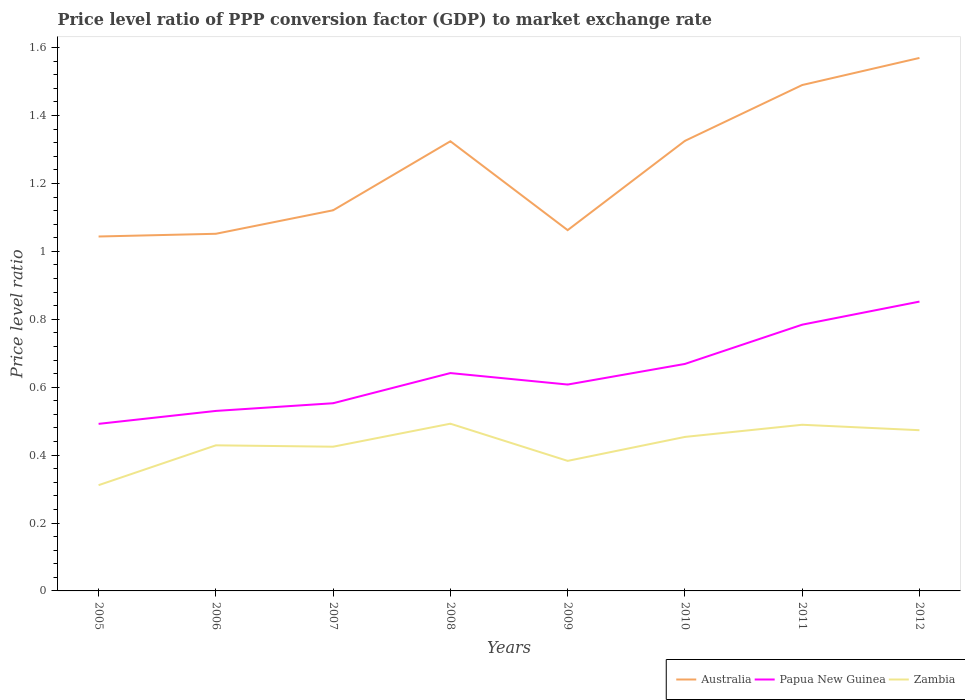Across all years, what is the maximum price level ratio in Zambia?
Offer a terse response. 0.31. What is the total price level ratio in Australia in the graph?
Offer a terse response. -0.27. What is the difference between the highest and the second highest price level ratio in Australia?
Offer a terse response. 0.53. What is the difference between the highest and the lowest price level ratio in Papua New Guinea?
Offer a terse response. 4. Is the price level ratio in Papua New Guinea strictly greater than the price level ratio in Australia over the years?
Provide a succinct answer. Yes. How many lines are there?
Make the answer very short. 3. How many years are there in the graph?
Provide a succinct answer. 8. Does the graph contain any zero values?
Your response must be concise. No. What is the title of the graph?
Your answer should be very brief. Price level ratio of PPP conversion factor (GDP) to market exchange rate. What is the label or title of the Y-axis?
Provide a succinct answer. Price level ratio. What is the Price level ratio of Australia in 2005?
Keep it short and to the point. 1.04. What is the Price level ratio of Papua New Guinea in 2005?
Ensure brevity in your answer.  0.49. What is the Price level ratio of Zambia in 2005?
Make the answer very short. 0.31. What is the Price level ratio of Australia in 2006?
Your answer should be compact. 1.05. What is the Price level ratio in Papua New Guinea in 2006?
Your answer should be compact. 0.53. What is the Price level ratio in Zambia in 2006?
Provide a succinct answer. 0.43. What is the Price level ratio of Australia in 2007?
Provide a short and direct response. 1.12. What is the Price level ratio in Papua New Guinea in 2007?
Keep it short and to the point. 0.55. What is the Price level ratio of Zambia in 2007?
Ensure brevity in your answer.  0.42. What is the Price level ratio in Australia in 2008?
Keep it short and to the point. 1.32. What is the Price level ratio of Papua New Guinea in 2008?
Give a very brief answer. 0.64. What is the Price level ratio in Zambia in 2008?
Your answer should be very brief. 0.49. What is the Price level ratio of Australia in 2009?
Your answer should be compact. 1.06. What is the Price level ratio in Papua New Guinea in 2009?
Your answer should be very brief. 0.61. What is the Price level ratio of Zambia in 2009?
Your response must be concise. 0.38. What is the Price level ratio of Australia in 2010?
Offer a very short reply. 1.33. What is the Price level ratio of Papua New Guinea in 2010?
Ensure brevity in your answer.  0.67. What is the Price level ratio in Zambia in 2010?
Keep it short and to the point. 0.45. What is the Price level ratio of Australia in 2011?
Provide a succinct answer. 1.49. What is the Price level ratio in Papua New Guinea in 2011?
Provide a short and direct response. 0.78. What is the Price level ratio in Zambia in 2011?
Make the answer very short. 0.49. What is the Price level ratio in Australia in 2012?
Provide a succinct answer. 1.57. What is the Price level ratio in Papua New Guinea in 2012?
Your answer should be very brief. 0.85. What is the Price level ratio of Zambia in 2012?
Your answer should be very brief. 0.47. Across all years, what is the maximum Price level ratio in Australia?
Ensure brevity in your answer.  1.57. Across all years, what is the maximum Price level ratio in Papua New Guinea?
Keep it short and to the point. 0.85. Across all years, what is the maximum Price level ratio in Zambia?
Keep it short and to the point. 0.49. Across all years, what is the minimum Price level ratio in Australia?
Your answer should be compact. 1.04. Across all years, what is the minimum Price level ratio of Papua New Guinea?
Provide a short and direct response. 0.49. Across all years, what is the minimum Price level ratio in Zambia?
Give a very brief answer. 0.31. What is the total Price level ratio in Australia in the graph?
Give a very brief answer. 9.99. What is the total Price level ratio in Papua New Guinea in the graph?
Offer a terse response. 5.13. What is the total Price level ratio of Zambia in the graph?
Provide a succinct answer. 3.46. What is the difference between the Price level ratio of Australia in 2005 and that in 2006?
Ensure brevity in your answer.  -0.01. What is the difference between the Price level ratio of Papua New Guinea in 2005 and that in 2006?
Make the answer very short. -0.04. What is the difference between the Price level ratio of Zambia in 2005 and that in 2006?
Provide a short and direct response. -0.12. What is the difference between the Price level ratio in Australia in 2005 and that in 2007?
Give a very brief answer. -0.08. What is the difference between the Price level ratio in Papua New Guinea in 2005 and that in 2007?
Keep it short and to the point. -0.06. What is the difference between the Price level ratio of Zambia in 2005 and that in 2007?
Your answer should be compact. -0.11. What is the difference between the Price level ratio in Australia in 2005 and that in 2008?
Offer a very short reply. -0.28. What is the difference between the Price level ratio in Papua New Guinea in 2005 and that in 2008?
Provide a short and direct response. -0.15. What is the difference between the Price level ratio of Zambia in 2005 and that in 2008?
Keep it short and to the point. -0.18. What is the difference between the Price level ratio of Australia in 2005 and that in 2009?
Give a very brief answer. -0.02. What is the difference between the Price level ratio of Papua New Guinea in 2005 and that in 2009?
Ensure brevity in your answer.  -0.12. What is the difference between the Price level ratio of Zambia in 2005 and that in 2009?
Offer a terse response. -0.07. What is the difference between the Price level ratio in Australia in 2005 and that in 2010?
Your answer should be compact. -0.28. What is the difference between the Price level ratio in Papua New Guinea in 2005 and that in 2010?
Provide a succinct answer. -0.18. What is the difference between the Price level ratio in Zambia in 2005 and that in 2010?
Provide a short and direct response. -0.14. What is the difference between the Price level ratio in Australia in 2005 and that in 2011?
Provide a short and direct response. -0.45. What is the difference between the Price level ratio of Papua New Guinea in 2005 and that in 2011?
Make the answer very short. -0.29. What is the difference between the Price level ratio of Zambia in 2005 and that in 2011?
Keep it short and to the point. -0.18. What is the difference between the Price level ratio in Australia in 2005 and that in 2012?
Provide a succinct answer. -0.53. What is the difference between the Price level ratio in Papua New Guinea in 2005 and that in 2012?
Give a very brief answer. -0.36. What is the difference between the Price level ratio in Zambia in 2005 and that in 2012?
Your answer should be compact. -0.16. What is the difference between the Price level ratio in Australia in 2006 and that in 2007?
Keep it short and to the point. -0.07. What is the difference between the Price level ratio in Papua New Guinea in 2006 and that in 2007?
Your answer should be compact. -0.02. What is the difference between the Price level ratio of Zambia in 2006 and that in 2007?
Make the answer very short. 0. What is the difference between the Price level ratio of Australia in 2006 and that in 2008?
Make the answer very short. -0.27. What is the difference between the Price level ratio of Papua New Guinea in 2006 and that in 2008?
Your response must be concise. -0.11. What is the difference between the Price level ratio of Zambia in 2006 and that in 2008?
Make the answer very short. -0.06. What is the difference between the Price level ratio in Australia in 2006 and that in 2009?
Offer a terse response. -0.01. What is the difference between the Price level ratio in Papua New Guinea in 2006 and that in 2009?
Your answer should be very brief. -0.08. What is the difference between the Price level ratio in Zambia in 2006 and that in 2009?
Give a very brief answer. 0.05. What is the difference between the Price level ratio in Australia in 2006 and that in 2010?
Offer a terse response. -0.27. What is the difference between the Price level ratio of Papua New Guinea in 2006 and that in 2010?
Your answer should be very brief. -0.14. What is the difference between the Price level ratio of Zambia in 2006 and that in 2010?
Ensure brevity in your answer.  -0.02. What is the difference between the Price level ratio in Australia in 2006 and that in 2011?
Your answer should be compact. -0.44. What is the difference between the Price level ratio in Papua New Guinea in 2006 and that in 2011?
Your answer should be compact. -0.25. What is the difference between the Price level ratio in Zambia in 2006 and that in 2011?
Your answer should be compact. -0.06. What is the difference between the Price level ratio of Australia in 2006 and that in 2012?
Your response must be concise. -0.52. What is the difference between the Price level ratio in Papua New Guinea in 2006 and that in 2012?
Offer a very short reply. -0.32. What is the difference between the Price level ratio of Zambia in 2006 and that in 2012?
Give a very brief answer. -0.04. What is the difference between the Price level ratio of Australia in 2007 and that in 2008?
Provide a short and direct response. -0.2. What is the difference between the Price level ratio in Papua New Guinea in 2007 and that in 2008?
Give a very brief answer. -0.09. What is the difference between the Price level ratio of Zambia in 2007 and that in 2008?
Offer a terse response. -0.07. What is the difference between the Price level ratio in Australia in 2007 and that in 2009?
Offer a very short reply. 0.06. What is the difference between the Price level ratio in Papua New Guinea in 2007 and that in 2009?
Offer a terse response. -0.06. What is the difference between the Price level ratio in Zambia in 2007 and that in 2009?
Keep it short and to the point. 0.04. What is the difference between the Price level ratio in Australia in 2007 and that in 2010?
Ensure brevity in your answer.  -0.2. What is the difference between the Price level ratio of Papua New Guinea in 2007 and that in 2010?
Give a very brief answer. -0.12. What is the difference between the Price level ratio in Zambia in 2007 and that in 2010?
Provide a short and direct response. -0.03. What is the difference between the Price level ratio of Australia in 2007 and that in 2011?
Provide a succinct answer. -0.37. What is the difference between the Price level ratio in Papua New Guinea in 2007 and that in 2011?
Your response must be concise. -0.23. What is the difference between the Price level ratio of Zambia in 2007 and that in 2011?
Offer a very short reply. -0.06. What is the difference between the Price level ratio in Australia in 2007 and that in 2012?
Provide a short and direct response. -0.45. What is the difference between the Price level ratio of Papua New Guinea in 2007 and that in 2012?
Ensure brevity in your answer.  -0.3. What is the difference between the Price level ratio of Zambia in 2007 and that in 2012?
Your response must be concise. -0.05. What is the difference between the Price level ratio of Australia in 2008 and that in 2009?
Make the answer very short. 0.26. What is the difference between the Price level ratio in Papua New Guinea in 2008 and that in 2009?
Offer a very short reply. 0.03. What is the difference between the Price level ratio in Zambia in 2008 and that in 2009?
Offer a very short reply. 0.11. What is the difference between the Price level ratio in Australia in 2008 and that in 2010?
Provide a short and direct response. -0. What is the difference between the Price level ratio in Papua New Guinea in 2008 and that in 2010?
Provide a short and direct response. -0.03. What is the difference between the Price level ratio of Zambia in 2008 and that in 2010?
Ensure brevity in your answer.  0.04. What is the difference between the Price level ratio in Australia in 2008 and that in 2011?
Provide a short and direct response. -0.17. What is the difference between the Price level ratio of Papua New Guinea in 2008 and that in 2011?
Give a very brief answer. -0.14. What is the difference between the Price level ratio of Zambia in 2008 and that in 2011?
Your answer should be very brief. 0. What is the difference between the Price level ratio in Australia in 2008 and that in 2012?
Your response must be concise. -0.25. What is the difference between the Price level ratio in Papua New Guinea in 2008 and that in 2012?
Provide a short and direct response. -0.21. What is the difference between the Price level ratio in Zambia in 2008 and that in 2012?
Provide a short and direct response. 0.02. What is the difference between the Price level ratio in Australia in 2009 and that in 2010?
Provide a short and direct response. -0.26. What is the difference between the Price level ratio of Papua New Guinea in 2009 and that in 2010?
Your answer should be compact. -0.06. What is the difference between the Price level ratio of Zambia in 2009 and that in 2010?
Your answer should be compact. -0.07. What is the difference between the Price level ratio of Australia in 2009 and that in 2011?
Provide a short and direct response. -0.43. What is the difference between the Price level ratio of Papua New Guinea in 2009 and that in 2011?
Make the answer very short. -0.18. What is the difference between the Price level ratio of Zambia in 2009 and that in 2011?
Ensure brevity in your answer.  -0.11. What is the difference between the Price level ratio of Australia in 2009 and that in 2012?
Make the answer very short. -0.51. What is the difference between the Price level ratio of Papua New Guinea in 2009 and that in 2012?
Give a very brief answer. -0.24. What is the difference between the Price level ratio in Zambia in 2009 and that in 2012?
Offer a terse response. -0.09. What is the difference between the Price level ratio in Australia in 2010 and that in 2011?
Your answer should be very brief. -0.16. What is the difference between the Price level ratio of Papua New Guinea in 2010 and that in 2011?
Your answer should be compact. -0.12. What is the difference between the Price level ratio in Zambia in 2010 and that in 2011?
Provide a succinct answer. -0.04. What is the difference between the Price level ratio in Australia in 2010 and that in 2012?
Make the answer very short. -0.24. What is the difference between the Price level ratio of Papua New Guinea in 2010 and that in 2012?
Offer a very short reply. -0.18. What is the difference between the Price level ratio in Zambia in 2010 and that in 2012?
Keep it short and to the point. -0.02. What is the difference between the Price level ratio of Australia in 2011 and that in 2012?
Your answer should be very brief. -0.08. What is the difference between the Price level ratio of Papua New Guinea in 2011 and that in 2012?
Give a very brief answer. -0.07. What is the difference between the Price level ratio of Zambia in 2011 and that in 2012?
Provide a succinct answer. 0.02. What is the difference between the Price level ratio in Australia in 2005 and the Price level ratio in Papua New Guinea in 2006?
Provide a succinct answer. 0.51. What is the difference between the Price level ratio in Australia in 2005 and the Price level ratio in Zambia in 2006?
Your answer should be very brief. 0.61. What is the difference between the Price level ratio in Papua New Guinea in 2005 and the Price level ratio in Zambia in 2006?
Your answer should be compact. 0.06. What is the difference between the Price level ratio of Australia in 2005 and the Price level ratio of Papua New Guinea in 2007?
Give a very brief answer. 0.49. What is the difference between the Price level ratio in Australia in 2005 and the Price level ratio in Zambia in 2007?
Keep it short and to the point. 0.62. What is the difference between the Price level ratio in Papua New Guinea in 2005 and the Price level ratio in Zambia in 2007?
Offer a very short reply. 0.07. What is the difference between the Price level ratio of Australia in 2005 and the Price level ratio of Papua New Guinea in 2008?
Provide a short and direct response. 0.4. What is the difference between the Price level ratio in Australia in 2005 and the Price level ratio in Zambia in 2008?
Ensure brevity in your answer.  0.55. What is the difference between the Price level ratio in Papua New Guinea in 2005 and the Price level ratio in Zambia in 2008?
Give a very brief answer. -0. What is the difference between the Price level ratio in Australia in 2005 and the Price level ratio in Papua New Guinea in 2009?
Provide a succinct answer. 0.44. What is the difference between the Price level ratio of Australia in 2005 and the Price level ratio of Zambia in 2009?
Give a very brief answer. 0.66. What is the difference between the Price level ratio of Papua New Guinea in 2005 and the Price level ratio of Zambia in 2009?
Give a very brief answer. 0.11. What is the difference between the Price level ratio of Australia in 2005 and the Price level ratio of Papua New Guinea in 2010?
Your answer should be compact. 0.38. What is the difference between the Price level ratio of Australia in 2005 and the Price level ratio of Zambia in 2010?
Provide a short and direct response. 0.59. What is the difference between the Price level ratio in Papua New Guinea in 2005 and the Price level ratio in Zambia in 2010?
Your response must be concise. 0.04. What is the difference between the Price level ratio of Australia in 2005 and the Price level ratio of Papua New Guinea in 2011?
Your response must be concise. 0.26. What is the difference between the Price level ratio of Australia in 2005 and the Price level ratio of Zambia in 2011?
Offer a terse response. 0.55. What is the difference between the Price level ratio of Papua New Guinea in 2005 and the Price level ratio of Zambia in 2011?
Ensure brevity in your answer.  0. What is the difference between the Price level ratio of Australia in 2005 and the Price level ratio of Papua New Guinea in 2012?
Ensure brevity in your answer.  0.19. What is the difference between the Price level ratio of Australia in 2005 and the Price level ratio of Zambia in 2012?
Keep it short and to the point. 0.57. What is the difference between the Price level ratio in Papua New Guinea in 2005 and the Price level ratio in Zambia in 2012?
Give a very brief answer. 0.02. What is the difference between the Price level ratio in Australia in 2006 and the Price level ratio in Papua New Guinea in 2007?
Give a very brief answer. 0.5. What is the difference between the Price level ratio of Australia in 2006 and the Price level ratio of Zambia in 2007?
Offer a very short reply. 0.63. What is the difference between the Price level ratio in Papua New Guinea in 2006 and the Price level ratio in Zambia in 2007?
Keep it short and to the point. 0.11. What is the difference between the Price level ratio in Australia in 2006 and the Price level ratio in Papua New Guinea in 2008?
Offer a very short reply. 0.41. What is the difference between the Price level ratio in Australia in 2006 and the Price level ratio in Zambia in 2008?
Offer a terse response. 0.56. What is the difference between the Price level ratio in Papua New Guinea in 2006 and the Price level ratio in Zambia in 2008?
Your answer should be very brief. 0.04. What is the difference between the Price level ratio in Australia in 2006 and the Price level ratio in Papua New Guinea in 2009?
Provide a succinct answer. 0.44. What is the difference between the Price level ratio of Australia in 2006 and the Price level ratio of Zambia in 2009?
Your answer should be very brief. 0.67. What is the difference between the Price level ratio in Papua New Guinea in 2006 and the Price level ratio in Zambia in 2009?
Ensure brevity in your answer.  0.15. What is the difference between the Price level ratio in Australia in 2006 and the Price level ratio in Papua New Guinea in 2010?
Your response must be concise. 0.38. What is the difference between the Price level ratio of Australia in 2006 and the Price level ratio of Zambia in 2010?
Provide a succinct answer. 0.6. What is the difference between the Price level ratio of Papua New Guinea in 2006 and the Price level ratio of Zambia in 2010?
Offer a terse response. 0.08. What is the difference between the Price level ratio of Australia in 2006 and the Price level ratio of Papua New Guinea in 2011?
Offer a very short reply. 0.27. What is the difference between the Price level ratio in Australia in 2006 and the Price level ratio in Zambia in 2011?
Ensure brevity in your answer.  0.56. What is the difference between the Price level ratio of Papua New Guinea in 2006 and the Price level ratio of Zambia in 2011?
Keep it short and to the point. 0.04. What is the difference between the Price level ratio in Australia in 2006 and the Price level ratio in Papua New Guinea in 2012?
Keep it short and to the point. 0.2. What is the difference between the Price level ratio of Australia in 2006 and the Price level ratio of Zambia in 2012?
Your answer should be compact. 0.58. What is the difference between the Price level ratio of Papua New Guinea in 2006 and the Price level ratio of Zambia in 2012?
Give a very brief answer. 0.06. What is the difference between the Price level ratio in Australia in 2007 and the Price level ratio in Papua New Guinea in 2008?
Offer a terse response. 0.48. What is the difference between the Price level ratio in Australia in 2007 and the Price level ratio in Zambia in 2008?
Make the answer very short. 0.63. What is the difference between the Price level ratio in Papua New Guinea in 2007 and the Price level ratio in Zambia in 2008?
Offer a terse response. 0.06. What is the difference between the Price level ratio in Australia in 2007 and the Price level ratio in Papua New Guinea in 2009?
Provide a short and direct response. 0.51. What is the difference between the Price level ratio in Australia in 2007 and the Price level ratio in Zambia in 2009?
Your answer should be compact. 0.74. What is the difference between the Price level ratio in Papua New Guinea in 2007 and the Price level ratio in Zambia in 2009?
Provide a short and direct response. 0.17. What is the difference between the Price level ratio in Australia in 2007 and the Price level ratio in Papua New Guinea in 2010?
Ensure brevity in your answer.  0.45. What is the difference between the Price level ratio in Australia in 2007 and the Price level ratio in Zambia in 2010?
Your answer should be very brief. 0.67. What is the difference between the Price level ratio in Papua New Guinea in 2007 and the Price level ratio in Zambia in 2010?
Your response must be concise. 0.1. What is the difference between the Price level ratio in Australia in 2007 and the Price level ratio in Papua New Guinea in 2011?
Keep it short and to the point. 0.34. What is the difference between the Price level ratio of Australia in 2007 and the Price level ratio of Zambia in 2011?
Your answer should be very brief. 0.63. What is the difference between the Price level ratio in Papua New Guinea in 2007 and the Price level ratio in Zambia in 2011?
Your response must be concise. 0.06. What is the difference between the Price level ratio of Australia in 2007 and the Price level ratio of Papua New Guinea in 2012?
Make the answer very short. 0.27. What is the difference between the Price level ratio in Australia in 2007 and the Price level ratio in Zambia in 2012?
Offer a very short reply. 0.65. What is the difference between the Price level ratio of Papua New Guinea in 2007 and the Price level ratio of Zambia in 2012?
Give a very brief answer. 0.08. What is the difference between the Price level ratio in Australia in 2008 and the Price level ratio in Papua New Guinea in 2009?
Ensure brevity in your answer.  0.72. What is the difference between the Price level ratio in Australia in 2008 and the Price level ratio in Zambia in 2009?
Provide a short and direct response. 0.94. What is the difference between the Price level ratio of Papua New Guinea in 2008 and the Price level ratio of Zambia in 2009?
Offer a very short reply. 0.26. What is the difference between the Price level ratio of Australia in 2008 and the Price level ratio of Papua New Guinea in 2010?
Provide a short and direct response. 0.66. What is the difference between the Price level ratio of Australia in 2008 and the Price level ratio of Zambia in 2010?
Give a very brief answer. 0.87. What is the difference between the Price level ratio of Papua New Guinea in 2008 and the Price level ratio of Zambia in 2010?
Provide a succinct answer. 0.19. What is the difference between the Price level ratio of Australia in 2008 and the Price level ratio of Papua New Guinea in 2011?
Give a very brief answer. 0.54. What is the difference between the Price level ratio of Australia in 2008 and the Price level ratio of Zambia in 2011?
Give a very brief answer. 0.83. What is the difference between the Price level ratio of Papua New Guinea in 2008 and the Price level ratio of Zambia in 2011?
Offer a terse response. 0.15. What is the difference between the Price level ratio of Australia in 2008 and the Price level ratio of Papua New Guinea in 2012?
Your answer should be compact. 0.47. What is the difference between the Price level ratio of Australia in 2008 and the Price level ratio of Zambia in 2012?
Offer a very short reply. 0.85. What is the difference between the Price level ratio in Papua New Guinea in 2008 and the Price level ratio in Zambia in 2012?
Your response must be concise. 0.17. What is the difference between the Price level ratio in Australia in 2009 and the Price level ratio in Papua New Guinea in 2010?
Give a very brief answer. 0.39. What is the difference between the Price level ratio in Australia in 2009 and the Price level ratio in Zambia in 2010?
Provide a short and direct response. 0.61. What is the difference between the Price level ratio in Papua New Guinea in 2009 and the Price level ratio in Zambia in 2010?
Provide a short and direct response. 0.15. What is the difference between the Price level ratio of Australia in 2009 and the Price level ratio of Papua New Guinea in 2011?
Ensure brevity in your answer.  0.28. What is the difference between the Price level ratio in Australia in 2009 and the Price level ratio in Zambia in 2011?
Your response must be concise. 0.57. What is the difference between the Price level ratio in Papua New Guinea in 2009 and the Price level ratio in Zambia in 2011?
Offer a very short reply. 0.12. What is the difference between the Price level ratio of Australia in 2009 and the Price level ratio of Papua New Guinea in 2012?
Give a very brief answer. 0.21. What is the difference between the Price level ratio of Australia in 2009 and the Price level ratio of Zambia in 2012?
Your response must be concise. 0.59. What is the difference between the Price level ratio of Papua New Guinea in 2009 and the Price level ratio of Zambia in 2012?
Make the answer very short. 0.13. What is the difference between the Price level ratio in Australia in 2010 and the Price level ratio in Papua New Guinea in 2011?
Your answer should be compact. 0.54. What is the difference between the Price level ratio in Australia in 2010 and the Price level ratio in Zambia in 2011?
Your answer should be compact. 0.84. What is the difference between the Price level ratio of Papua New Guinea in 2010 and the Price level ratio of Zambia in 2011?
Keep it short and to the point. 0.18. What is the difference between the Price level ratio of Australia in 2010 and the Price level ratio of Papua New Guinea in 2012?
Make the answer very short. 0.47. What is the difference between the Price level ratio of Australia in 2010 and the Price level ratio of Zambia in 2012?
Your response must be concise. 0.85. What is the difference between the Price level ratio in Papua New Guinea in 2010 and the Price level ratio in Zambia in 2012?
Give a very brief answer. 0.2. What is the difference between the Price level ratio in Australia in 2011 and the Price level ratio in Papua New Guinea in 2012?
Ensure brevity in your answer.  0.64. What is the difference between the Price level ratio in Australia in 2011 and the Price level ratio in Zambia in 2012?
Offer a terse response. 1.02. What is the difference between the Price level ratio in Papua New Guinea in 2011 and the Price level ratio in Zambia in 2012?
Your response must be concise. 0.31. What is the average Price level ratio in Australia per year?
Ensure brevity in your answer.  1.25. What is the average Price level ratio of Papua New Guinea per year?
Your answer should be very brief. 0.64. What is the average Price level ratio in Zambia per year?
Your response must be concise. 0.43. In the year 2005, what is the difference between the Price level ratio in Australia and Price level ratio in Papua New Guinea?
Make the answer very short. 0.55. In the year 2005, what is the difference between the Price level ratio of Australia and Price level ratio of Zambia?
Keep it short and to the point. 0.73. In the year 2005, what is the difference between the Price level ratio in Papua New Guinea and Price level ratio in Zambia?
Make the answer very short. 0.18. In the year 2006, what is the difference between the Price level ratio in Australia and Price level ratio in Papua New Guinea?
Your answer should be very brief. 0.52. In the year 2006, what is the difference between the Price level ratio of Australia and Price level ratio of Zambia?
Provide a succinct answer. 0.62. In the year 2006, what is the difference between the Price level ratio of Papua New Guinea and Price level ratio of Zambia?
Give a very brief answer. 0.1. In the year 2007, what is the difference between the Price level ratio in Australia and Price level ratio in Papua New Guinea?
Your answer should be compact. 0.57. In the year 2007, what is the difference between the Price level ratio in Australia and Price level ratio in Zambia?
Your response must be concise. 0.7. In the year 2007, what is the difference between the Price level ratio of Papua New Guinea and Price level ratio of Zambia?
Your answer should be very brief. 0.13. In the year 2008, what is the difference between the Price level ratio of Australia and Price level ratio of Papua New Guinea?
Make the answer very short. 0.68. In the year 2008, what is the difference between the Price level ratio in Australia and Price level ratio in Zambia?
Your response must be concise. 0.83. In the year 2008, what is the difference between the Price level ratio of Papua New Guinea and Price level ratio of Zambia?
Your answer should be very brief. 0.15. In the year 2009, what is the difference between the Price level ratio in Australia and Price level ratio in Papua New Guinea?
Your response must be concise. 0.45. In the year 2009, what is the difference between the Price level ratio of Australia and Price level ratio of Zambia?
Offer a very short reply. 0.68. In the year 2009, what is the difference between the Price level ratio in Papua New Guinea and Price level ratio in Zambia?
Ensure brevity in your answer.  0.22. In the year 2010, what is the difference between the Price level ratio of Australia and Price level ratio of Papua New Guinea?
Offer a very short reply. 0.66. In the year 2010, what is the difference between the Price level ratio of Australia and Price level ratio of Zambia?
Your answer should be compact. 0.87. In the year 2010, what is the difference between the Price level ratio in Papua New Guinea and Price level ratio in Zambia?
Ensure brevity in your answer.  0.21. In the year 2011, what is the difference between the Price level ratio of Australia and Price level ratio of Papua New Guinea?
Ensure brevity in your answer.  0.71. In the year 2011, what is the difference between the Price level ratio of Australia and Price level ratio of Zambia?
Ensure brevity in your answer.  1. In the year 2011, what is the difference between the Price level ratio in Papua New Guinea and Price level ratio in Zambia?
Your response must be concise. 0.29. In the year 2012, what is the difference between the Price level ratio of Australia and Price level ratio of Papua New Guinea?
Offer a terse response. 0.72. In the year 2012, what is the difference between the Price level ratio of Australia and Price level ratio of Zambia?
Offer a terse response. 1.1. In the year 2012, what is the difference between the Price level ratio in Papua New Guinea and Price level ratio in Zambia?
Ensure brevity in your answer.  0.38. What is the ratio of the Price level ratio in Papua New Guinea in 2005 to that in 2006?
Give a very brief answer. 0.93. What is the ratio of the Price level ratio in Zambia in 2005 to that in 2006?
Your answer should be compact. 0.73. What is the ratio of the Price level ratio of Australia in 2005 to that in 2007?
Provide a succinct answer. 0.93. What is the ratio of the Price level ratio in Papua New Guinea in 2005 to that in 2007?
Your answer should be compact. 0.89. What is the ratio of the Price level ratio of Zambia in 2005 to that in 2007?
Your answer should be very brief. 0.73. What is the ratio of the Price level ratio of Australia in 2005 to that in 2008?
Provide a succinct answer. 0.79. What is the ratio of the Price level ratio of Papua New Guinea in 2005 to that in 2008?
Keep it short and to the point. 0.77. What is the ratio of the Price level ratio in Zambia in 2005 to that in 2008?
Your response must be concise. 0.63. What is the ratio of the Price level ratio of Australia in 2005 to that in 2009?
Provide a short and direct response. 0.98. What is the ratio of the Price level ratio in Papua New Guinea in 2005 to that in 2009?
Provide a succinct answer. 0.81. What is the ratio of the Price level ratio of Zambia in 2005 to that in 2009?
Your answer should be compact. 0.81. What is the ratio of the Price level ratio in Australia in 2005 to that in 2010?
Provide a succinct answer. 0.79. What is the ratio of the Price level ratio of Papua New Guinea in 2005 to that in 2010?
Your answer should be compact. 0.74. What is the ratio of the Price level ratio in Zambia in 2005 to that in 2010?
Your answer should be compact. 0.69. What is the ratio of the Price level ratio in Australia in 2005 to that in 2011?
Your answer should be very brief. 0.7. What is the ratio of the Price level ratio of Papua New Guinea in 2005 to that in 2011?
Make the answer very short. 0.63. What is the ratio of the Price level ratio of Zambia in 2005 to that in 2011?
Provide a succinct answer. 0.64. What is the ratio of the Price level ratio of Australia in 2005 to that in 2012?
Your answer should be very brief. 0.67. What is the ratio of the Price level ratio in Papua New Guinea in 2005 to that in 2012?
Offer a very short reply. 0.58. What is the ratio of the Price level ratio in Zambia in 2005 to that in 2012?
Make the answer very short. 0.66. What is the ratio of the Price level ratio in Australia in 2006 to that in 2007?
Your answer should be very brief. 0.94. What is the ratio of the Price level ratio in Zambia in 2006 to that in 2007?
Your response must be concise. 1.01. What is the ratio of the Price level ratio of Australia in 2006 to that in 2008?
Your answer should be compact. 0.79. What is the ratio of the Price level ratio in Papua New Guinea in 2006 to that in 2008?
Offer a very short reply. 0.83. What is the ratio of the Price level ratio of Zambia in 2006 to that in 2008?
Your answer should be very brief. 0.87. What is the ratio of the Price level ratio of Papua New Guinea in 2006 to that in 2009?
Provide a succinct answer. 0.87. What is the ratio of the Price level ratio of Zambia in 2006 to that in 2009?
Your answer should be very brief. 1.12. What is the ratio of the Price level ratio in Australia in 2006 to that in 2010?
Provide a short and direct response. 0.79. What is the ratio of the Price level ratio of Papua New Guinea in 2006 to that in 2010?
Your answer should be very brief. 0.79. What is the ratio of the Price level ratio in Zambia in 2006 to that in 2010?
Offer a very short reply. 0.95. What is the ratio of the Price level ratio of Australia in 2006 to that in 2011?
Keep it short and to the point. 0.71. What is the ratio of the Price level ratio in Papua New Guinea in 2006 to that in 2011?
Your answer should be very brief. 0.68. What is the ratio of the Price level ratio in Zambia in 2006 to that in 2011?
Make the answer very short. 0.88. What is the ratio of the Price level ratio of Australia in 2006 to that in 2012?
Keep it short and to the point. 0.67. What is the ratio of the Price level ratio of Papua New Guinea in 2006 to that in 2012?
Offer a terse response. 0.62. What is the ratio of the Price level ratio in Zambia in 2006 to that in 2012?
Offer a very short reply. 0.91. What is the ratio of the Price level ratio in Australia in 2007 to that in 2008?
Make the answer very short. 0.85. What is the ratio of the Price level ratio of Papua New Guinea in 2007 to that in 2008?
Your answer should be compact. 0.86. What is the ratio of the Price level ratio of Zambia in 2007 to that in 2008?
Your answer should be compact. 0.86. What is the ratio of the Price level ratio in Australia in 2007 to that in 2009?
Provide a succinct answer. 1.06. What is the ratio of the Price level ratio of Papua New Guinea in 2007 to that in 2009?
Your answer should be compact. 0.91. What is the ratio of the Price level ratio of Zambia in 2007 to that in 2009?
Your response must be concise. 1.11. What is the ratio of the Price level ratio in Australia in 2007 to that in 2010?
Ensure brevity in your answer.  0.85. What is the ratio of the Price level ratio of Papua New Guinea in 2007 to that in 2010?
Give a very brief answer. 0.83. What is the ratio of the Price level ratio of Zambia in 2007 to that in 2010?
Your answer should be compact. 0.94. What is the ratio of the Price level ratio in Australia in 2007 to that in 2011?
Ensure brevity in your answer.  0.75. What is the ratio of the Price level ratio of Papua New Guinea in 2007 to that in 2011?
Provide a succinct answer. 0.7. What is the ratio of the Price level ratio of Zambia in 2007 to that in 2011?
Offer a very short reply. 0.87. What is the ratio of the Price level ratio of Australia in 2007 to that in 2012?
Ensure brevity in your answer.  0.71. What is the ratio of the Price level ratio in Papua New Guinea in 2007 to that in 2012?
Offer a very short reply. 0.65. What is the ratio of the Price level ratio of Zambia in 2007 to that in 2012?
Your answer should be compact. 0.9. What is the ratio of the Price level ratio in Australia in 2008 to that in 2009?
Make the answer very short. 1.25. What is the ratio of the Price level ratio in Papua New Guinea in 2008 to that in 2009?
Your answer should be very brief. 1.06. What is the ratio of the Price level ratio of Zambia in 2008 to that in 2009?
Offer a terse response. 1.29. What is the ratio of the Price level ratio in Australia in 2008 to that in 2010?
Provide a succinct answer. 1. What is the ratio of the Price level ratio in Papua New Guinea in 2008 to that in 2010?
Make the answer very short. 0.96. What is the ratio of the Price level ratio of Zambia in 2008 to that in 2010?
Provide a short and direct response. 1.09. What is the ratio of the Price level ratio in Australia in 2008 to that in 2011?
Keep it short and to the point. 0.89. What is the ratio of the Price level ratio of Papua New Guinea in 2008 to that in 2011?
Ensure brevity in your answer.  0.82. What is the ratio of the Price level ratio in Zambia in 2008 to that in 2011?
Your response must be concise. 1.01. What is the ratio of the Price level ratio of Australia in 2008 to that in 2012?
Your response must be concise. 0.84. What is the ratio of the Price level ratio of Papua New Guinea in 2008 to that in 2012?
Make the answer very short. 0.75. What is the ratio of the Price level ratio of Zambia in 2008 to that in 2012?
Keep it short and to the point. 1.04. What is the ratio of the Price level ratio in Australia in 2009 to that in 2010?
Your answer should be very brief. 0.8. What is the ratio of the Price level ratio in Papua New Guinea in 2009 to that in 2010?
Your answer should be compact. 0.91. What is the ratio of the Price level ratio of Zambia in 2009 to that in 2010?
Your answer should be compact. 0.84. What is the ratio of the Price level ratio of Australia in 2009 to that in 2011?
Provide a succinct answer. 0.71. What is the ratio of the Price level ratio in Papua New Guinea in 2009 to that in 2011?
Provide a short and direct response. 0.78. What is the ratio of the Price level ratio of Zambia in 2009 to that in 2011?
Your answer should be very brief. 0.78. What is the ratio of the Price level ratio of Australia in 2009 to that in 2012?
Your answer should be very brief. 0.68. What is the ratio of the Price level ratio in Papua New Guinea in 2009 to that in 2012?
Your response must be concise. 0.71. What is the ratio of the Price level ratio of Zambia in 2009 to that in 2012?
Ensure brevity in your answer.  0.81. What is the ratio of the Price level ratio of Australia in 2010 to that in 2011?
Keep it short and to the point. 0.89. What is the ratio of the Price level ratio in Papua New Guinea in 2010 to that in 2011?
Make the answer very short. 0.85. What is the ratio of the Price level ratio of Zambia in 2010 to that in 2011?
Keep it short and to the point. 0.93. What is the ratio of the Price level ratio in Australia in 2010 to that in 2012?
Offer a very short reply. 0.84. What is the ratio of the Price level ratio of Papua New Guinea in 2010 to that in 2012?
Provide a succinct answer. 0.78. What is the ratio of the Price level ratio in Zambia in 2010 to that in 2012?
Provide a short and direct response. 0.96. What is the ratio of the Price level ratio in Australia in 2011 to that in 2012?
Make the answer very short. 0.95. What is the ratio of the Price level ratio of Papua New Guinea in 2011 to that in 2012?
Your response must be concise. 0.92. What is the ratio of the Price level ratio of Zambia in 2011 to that in 2012?
Offer a very short reply. 1.03. What is the difference between the highest and the second highest Price level ratio in Australia?
Ensure brevity in your answer.  0.08. What is the difference between the highest and the second highest Price level ratio in Papua New Guinea?
Offer a terse response. 0.07. What is the difference between the highest and the second highest Price level ratio in Zambia?
Give a very brief answer. 0. What is the difference between the highest and the lowest Price level ratio in Australia?
Offer a very short reply. 0.53. What is the difference between the highest and the lowest Price level ratio of Papua New Guinea?
Provide a succinct answer. 0.36. What is the difference between the highest and the lowest Price level ratio of Zambia?
Your answer should be compact. 0.18. 